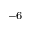Convert formula to latex. <formula><loc_0><loc_0><loc_500><loc_500>^ { - 6 }</formula> 